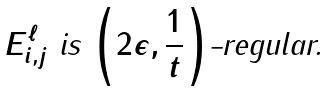<formula> <loc_0><loc_0><loc_500><loc_500>\text {\em $E^{\ell}_{i,j}$ is $\left(2\epsilon,\frac{1}{t}\right)$-regular.}</formula> 